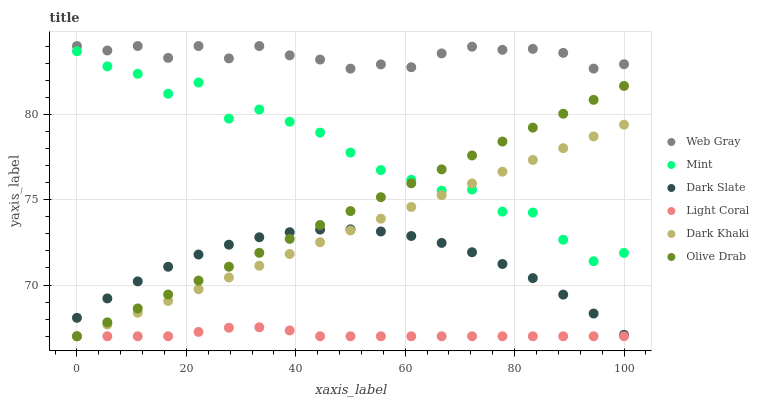Does Light Coral have the minimum area under the curve?
Answer yes or no. Yes. Does Web Gray have the maximum area under the curve?
Answer yes or no. Yes. Does Web Gray have the minimum area under the curve?
Answer yes or no. No. Does Light Coral have the maximum area under the curve?
Answer yes or no. No. Is Olive Drab the smoothest?
Answer yes or no. Yes. Is Mint the roughest?
Answer yes or no. Yes. Is Web Gray the smoothest?
Answer yes or no. No. Is Web Gray the roughest?
Answer yes or no. No. Does Dark Khaki have the lowest value?
Answer yes or no. Yes. Does Web Gray have the lowest value?
Answer yes or no. No. Does Web Gray have the highest value?
Answer yes or no. Yes. Does Light Coral have the highest value?
Answer yes or no. No. Is Light Coral less than Mint?
Answer yes or no. Yes. Is Web Gray greater than Dark Slate?
Answer yes or no. Yes. Does Olive Drab intersect Dark Slate?
Answer yes or no. Yes. Is Olive Drab less than Dark Slate?
Answer yes or no. No. Is Olive Drab greater than Dark Slate?
Answer yes or no. No. Does Light Coral intersect Mint?
Answer yes or no. No. 